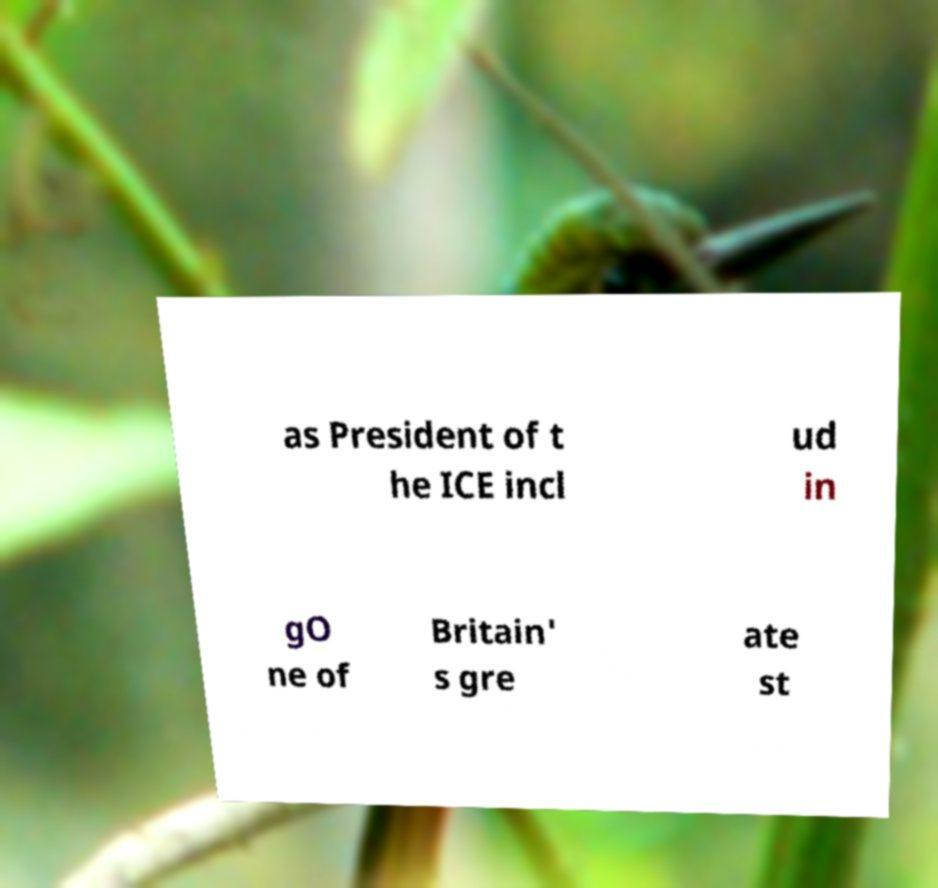I need the written content from this picture converted into text. Can you do that? as President of t he ICE incl ud in gO ne of Britain' s gre ate st 